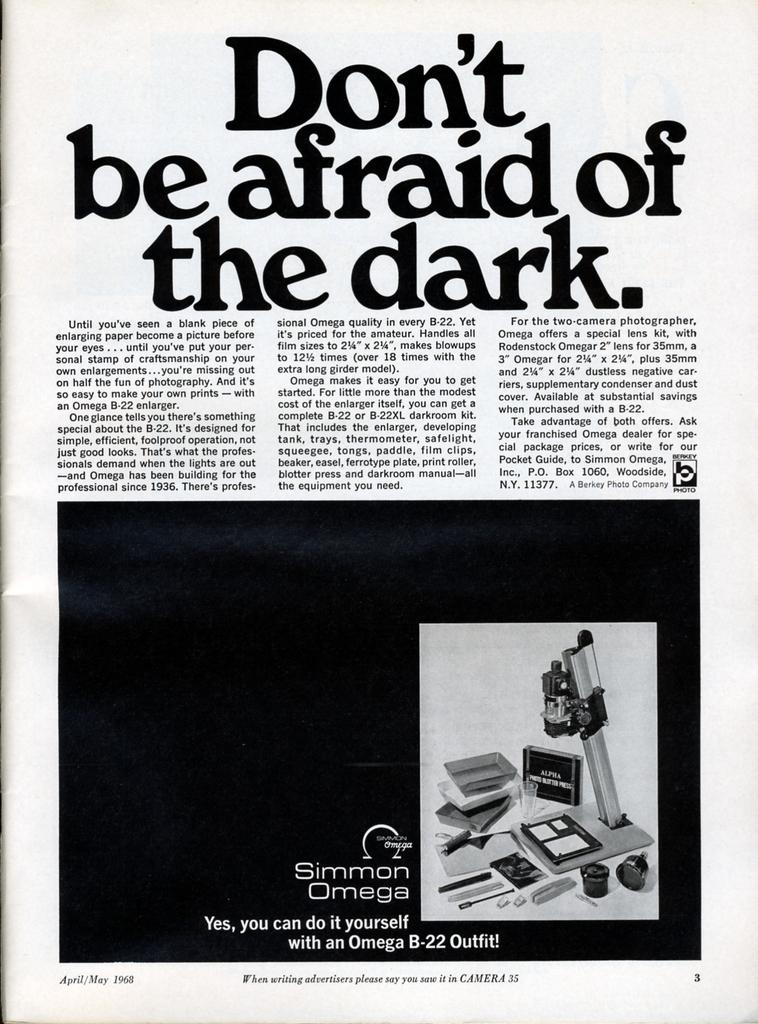<image>
Present a compact description of the photo's key features. an article thats titled don't be afraid of the dark in black and white. 